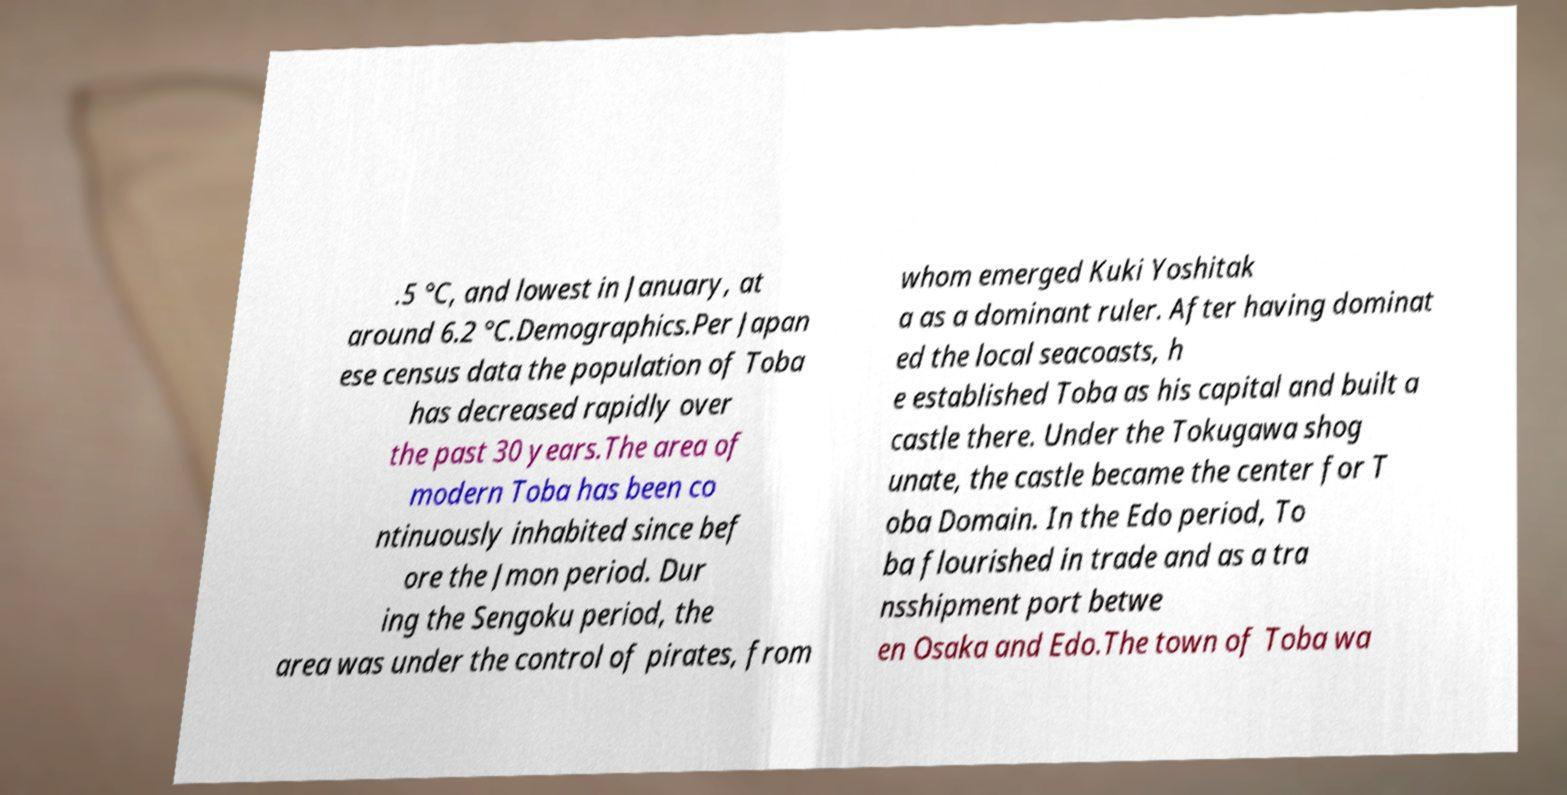Can you accurately transcribe the text from the provided image for me? .5 °C, and lowest in January, at around 6.2 °C.Demographics.Per Japan ese census data the population of Toba has decreased rapidly over the past 30 years.The area of modern Toba has been co ntinuously inhabited since bef ore the Jmon period. Dur ing the Sengoku period, the area was under the control of pirates, from whom emerged Kuki Yoshitak a as a dominant ruler. After having dominat ed the local seacoasts, h e established Toba as his capital and built a castle there. Under the Tokugawa shog unate, the castle became the center for T oba Domain. In the Edo period, To ba flourished in trade and as a tra nsshipment port betwe en Osaka and Edo.The town of Toba wa 